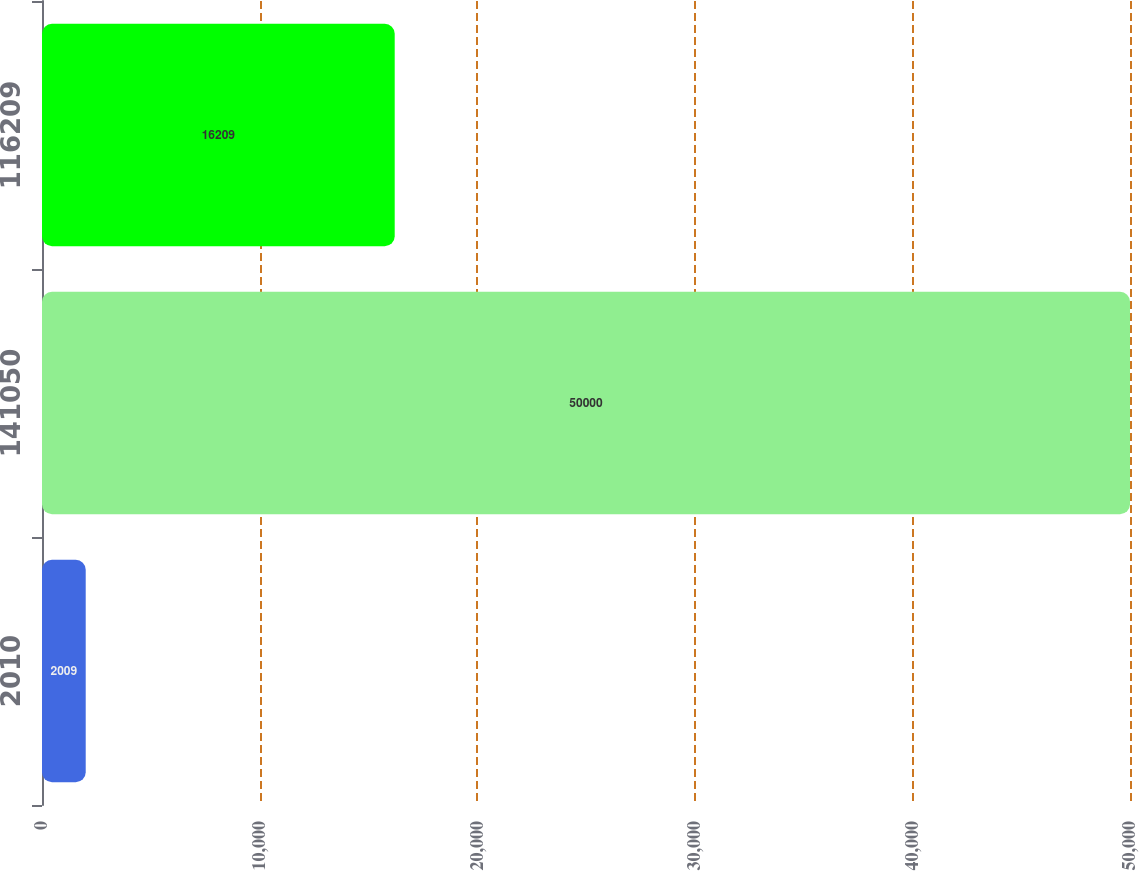Convert chart to OTSL. <chart><loc_0><loc_0><loc_500><loc_500><bar_chart><fcel>2010<fcel>141050<fcel>116209<nl><fcel>2009<fcel>50000<fcel>16209<nl></chart> 